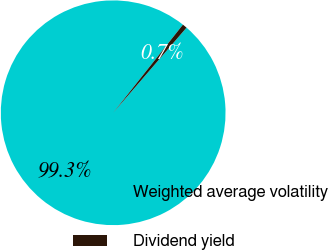<chart> <loc_0><loc_0><loc_500><loc_500><pie_chart><fcel>Weighted average volatility<fcel>Dividend yield<nl><fcel>99.34%<fcel>0.66%<nl></chart> 